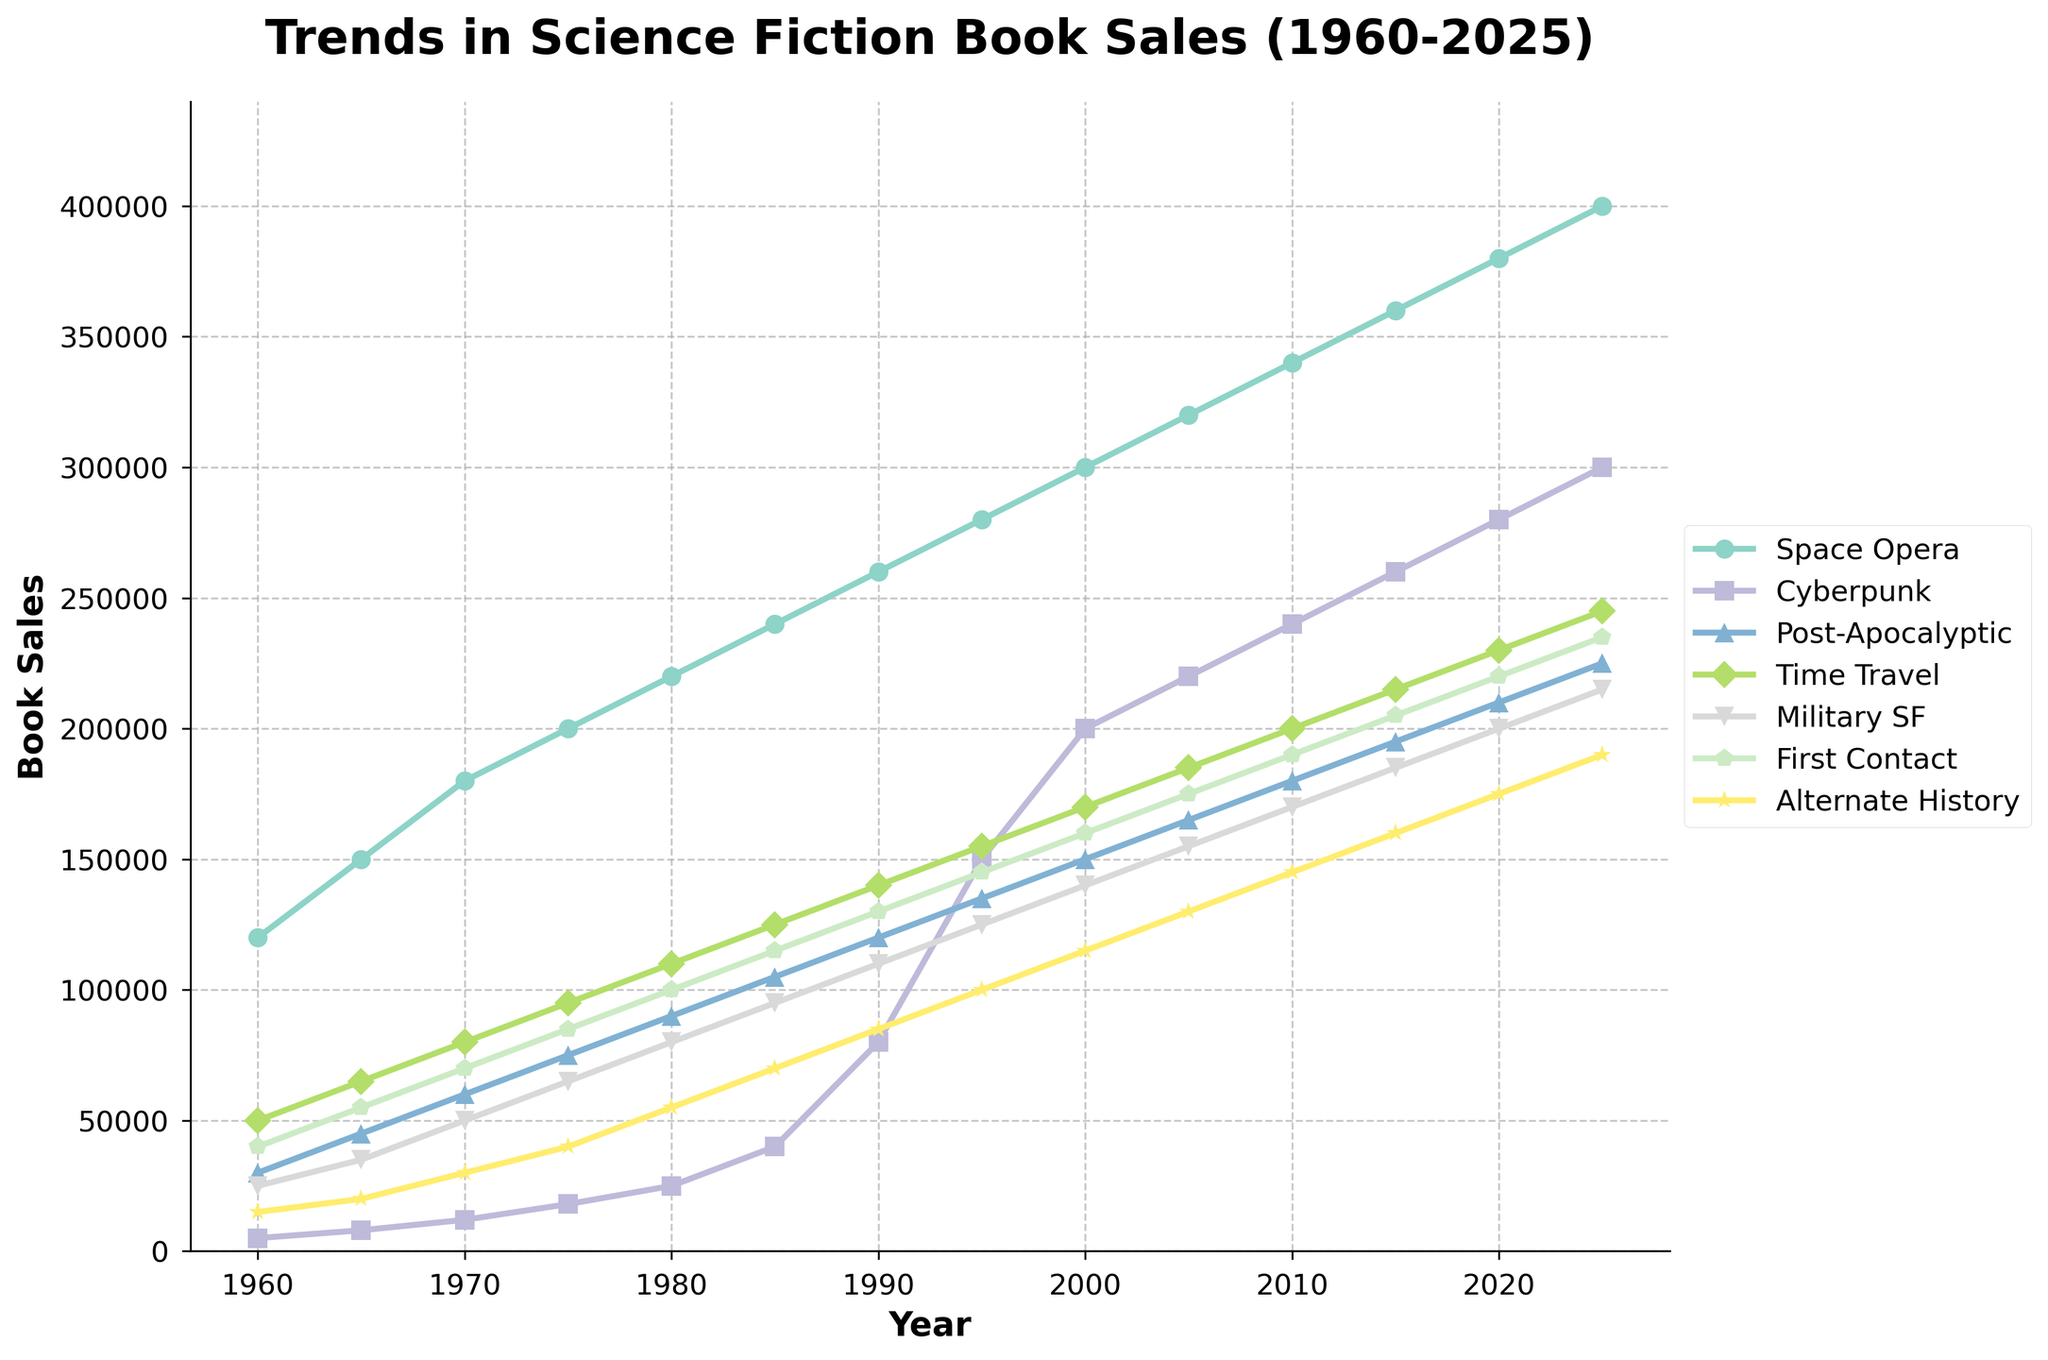What subgenre had the highest sales in 2025? Look at the end points of each line in the figure and find the highest one for 2025. The darkest color line (Space Opera) ends the highest.
Answer: Space Opera Which subgenre showed the most significant growth between 1960 and 2025? Check the starting and ending points for each subgenre, then calculate the difference and select the one with the highest increase. Space Opera goes from 120,000 to 400,000.
Answer: Space Opera How does the trend for Cyberpunk compare to that of Alternate History from 1985 to 2025? Trace both lines for these subgenres from 1985 to 2025. Cyberpunk shows a steeper and more significant rise than Alternate History during this period.
Answer: Cyberpunk grows faster Between 2000 and 2025, did Post-Apocalyptic sales increase more or less than Military SF sales? Identify both subgenres' values in 2000 and 2025, then compute their differences. Compare the differences: Post-Apocalyptic (225,000 - 150,000 = 75,000), Military SF (215,000 - 140,000 = 75,000).
Answer: Same increase What is the average sales growth per decade for Time Travel between 1960 and 2025? Determine sales every decade (1960, 1970, etc.), find the differences, sum them and divide by the number of decades (6). Steps: (65000 - 50000) + (80000 - 65000) + ... + (245000 - 230000) = 6000; 6000 / 6.
Answer: 10,000 Which subgenre had the smallest increase in sales from 1960 to 2025? Calculate the differences by subtracting sales in 1960 from 2025 for each subgenre and find the smallest one. First Contact has the smallest increment.
Answer: First Contact In 2025, how do the sales of Time Travel books compare visually to those of Military SF books? Compare the height of the markers at 2025 for Time Travel (245,000) to Military SF (215,000). Time Travel is higher.
Answer: Time Travel is higher Which subgenre overtook the sales of Cyberpunk between 1990 and 1995? Identify the lines crossing Cyberpunk's line between 1990 (80,000) and 1995 (150,000). Space Opera sales surpassed Cyberpunk during this period.
Answer: None 